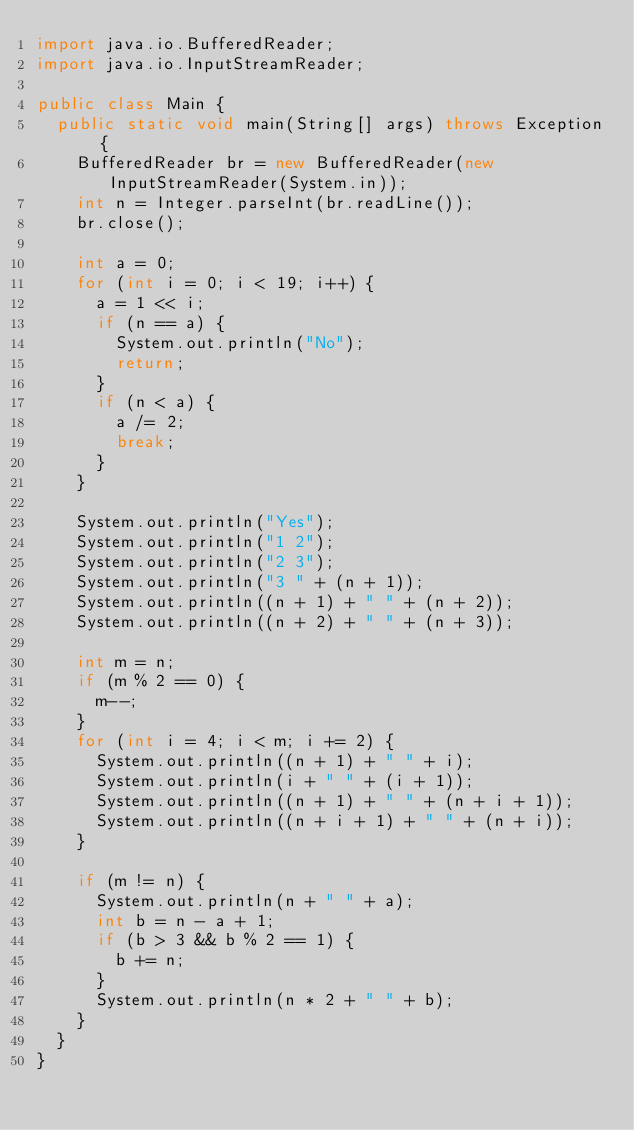<code> <loc_0><loc_0><loc_500><loc_500><_Java_>import java.io.BufferedReader;
import java.io.InputStreamReader;

public class Main {
	public static void main(String[] args) throws Exception {
		BufferedReader br = new BufferedReader(new InputStreamReader(System.in));
		int n = Integer.parseInt(br.readLine());
		br.close();

		int a = 0;
		for (int i = 0; i < 19; i++) {
			a = 1 << i;
			if (n == a) {
				System.out.println("No");
				return;
			}
			if (n < a) {
				a /= 2;
				break;
			}
		}

		System.out.println("Yes");
		System.out.println("1 2");
		System.out.println("2 3");
		System.out.println("3 " + (n + 1));
		System.out.println((n + 1) + " " + (n + 2));
		System.out.println((n + 2) + " " + (n + 3));

		int m = n;
		if (m % 2 == 0) {
			m--;
		}
		for (int i = 4; i < m; i += 2) {
			System.out.println((n + 1) + " " + i);
			System.out.println(i + " " + (i + 1));
			System.out.println((n + 1) + " " + (n + i + 1));
			System.out.println((n + i + 1) + " " + (n + i));
		}

		if (m != n) {
			System.out.println(n + " " + a);
			int b = n - a + 1;
			if (b > 3 && b % 2 == 1) {
				b += n;
			}
			System.out.println(n * 2 + " " + b);
		}
	}
}
</code> 